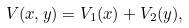Convert formula to latex. <formula><loc_0><loc_0><loc_500><loc_500>V ( x , y ) = V _ { 1 } ( x ) + V _ { 2 } ( y ) ,</formula> 